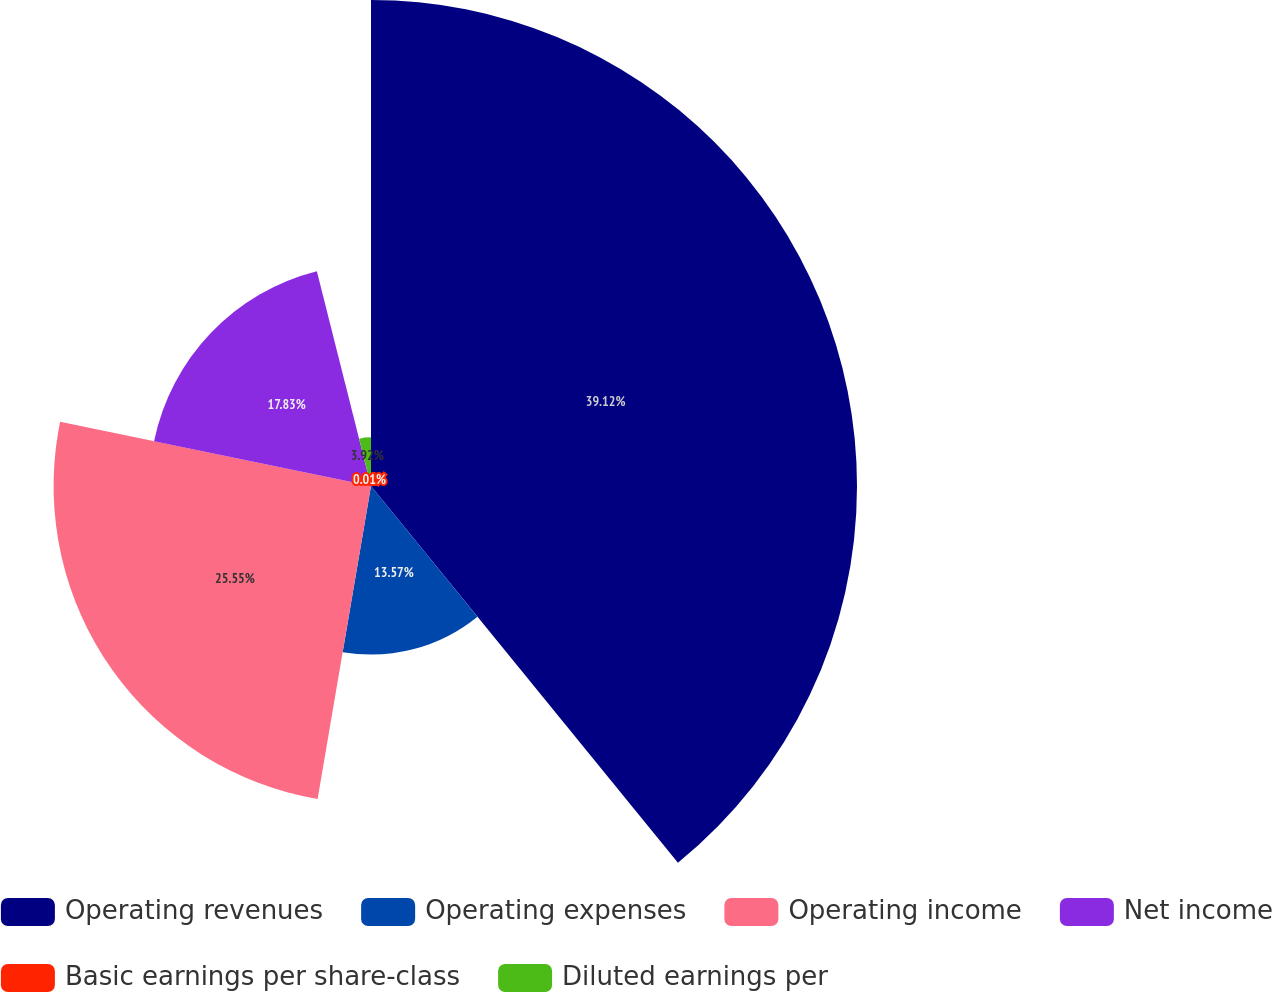<chart> <loc_0><loc_0><loc_500><loc_500><pie_chart><fcel>Operating revenues<fcel>Operating expenses<fcel>Operating income<fcel>Net income<fcel>Basic earnings per share-class<fcel>Diluted earnings per<nl><fcel>39.12%<fcel>13.57%<fcel>25.55%<fcel>17.83%<fcel>0.01%<fcel>3.92%<nl></chart> 